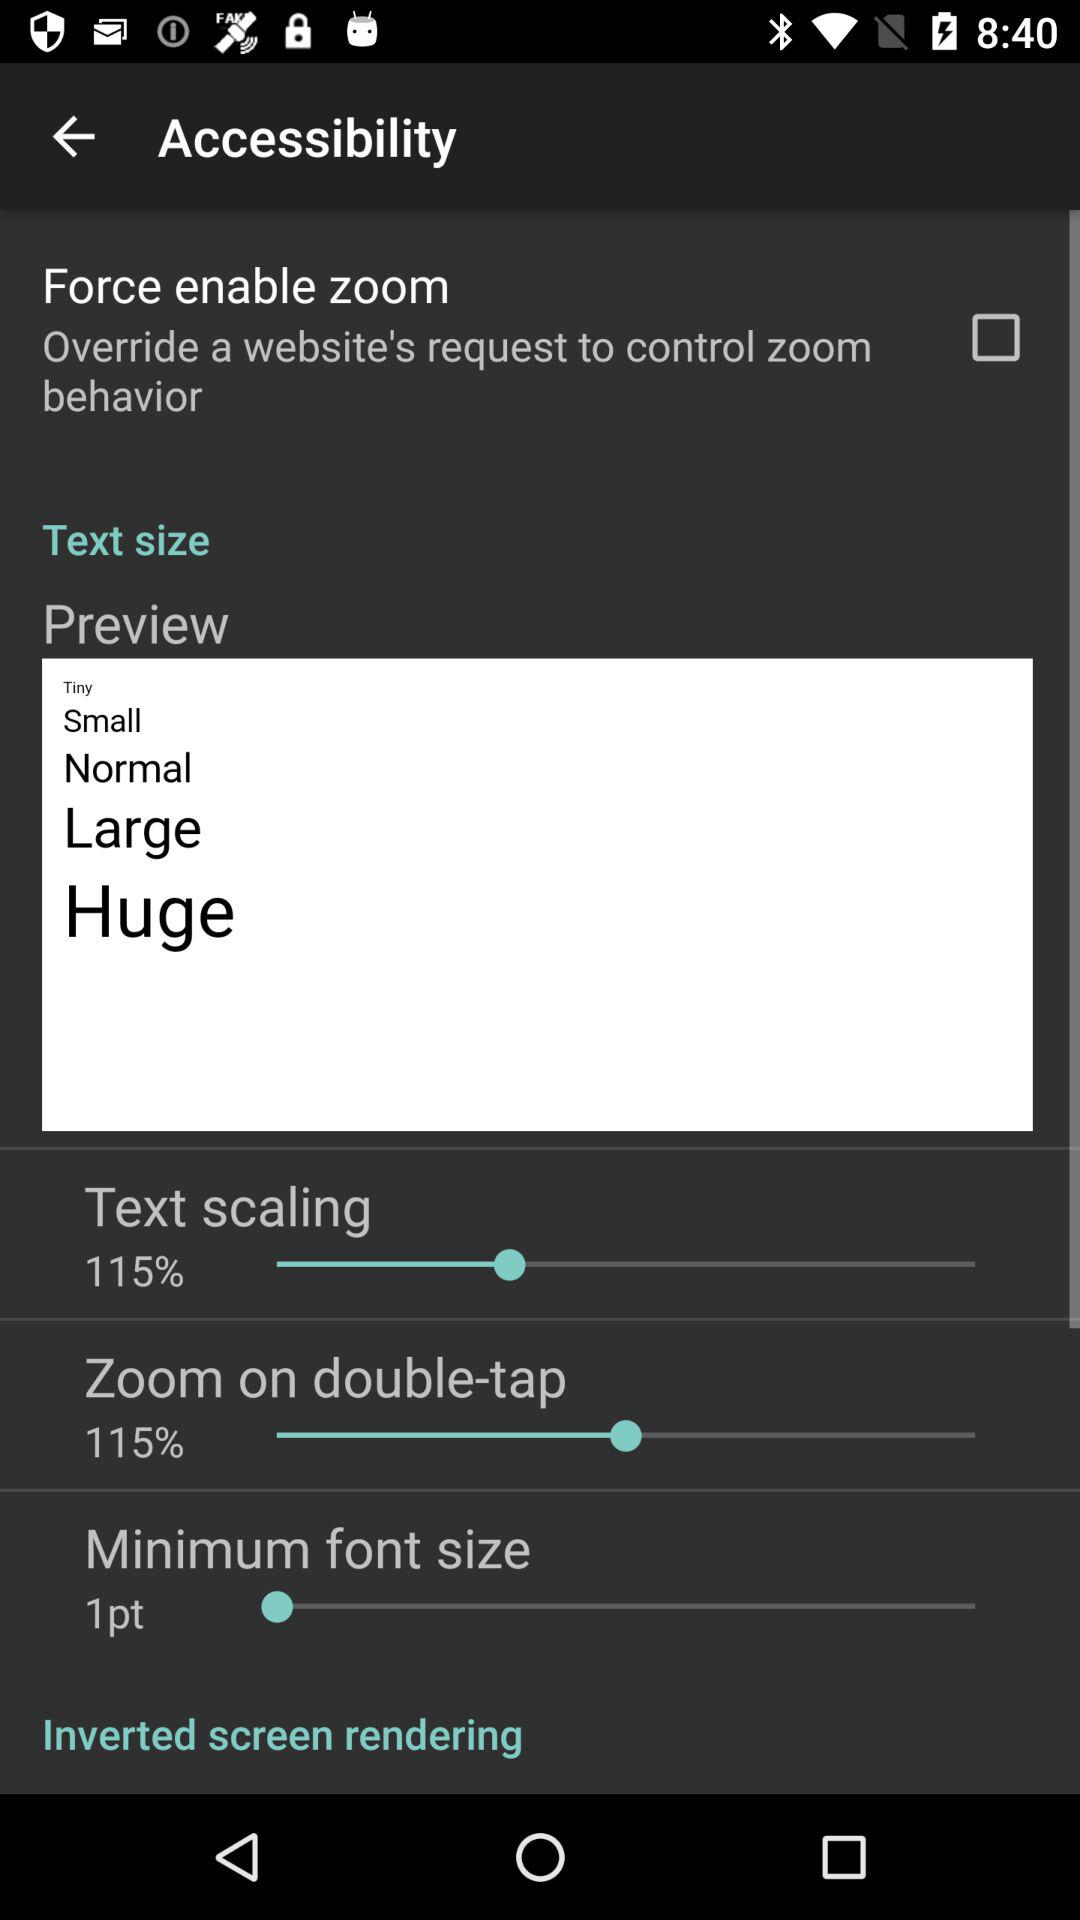What is the percentage of "Zoom on double- tap"? The percentage is 115. 